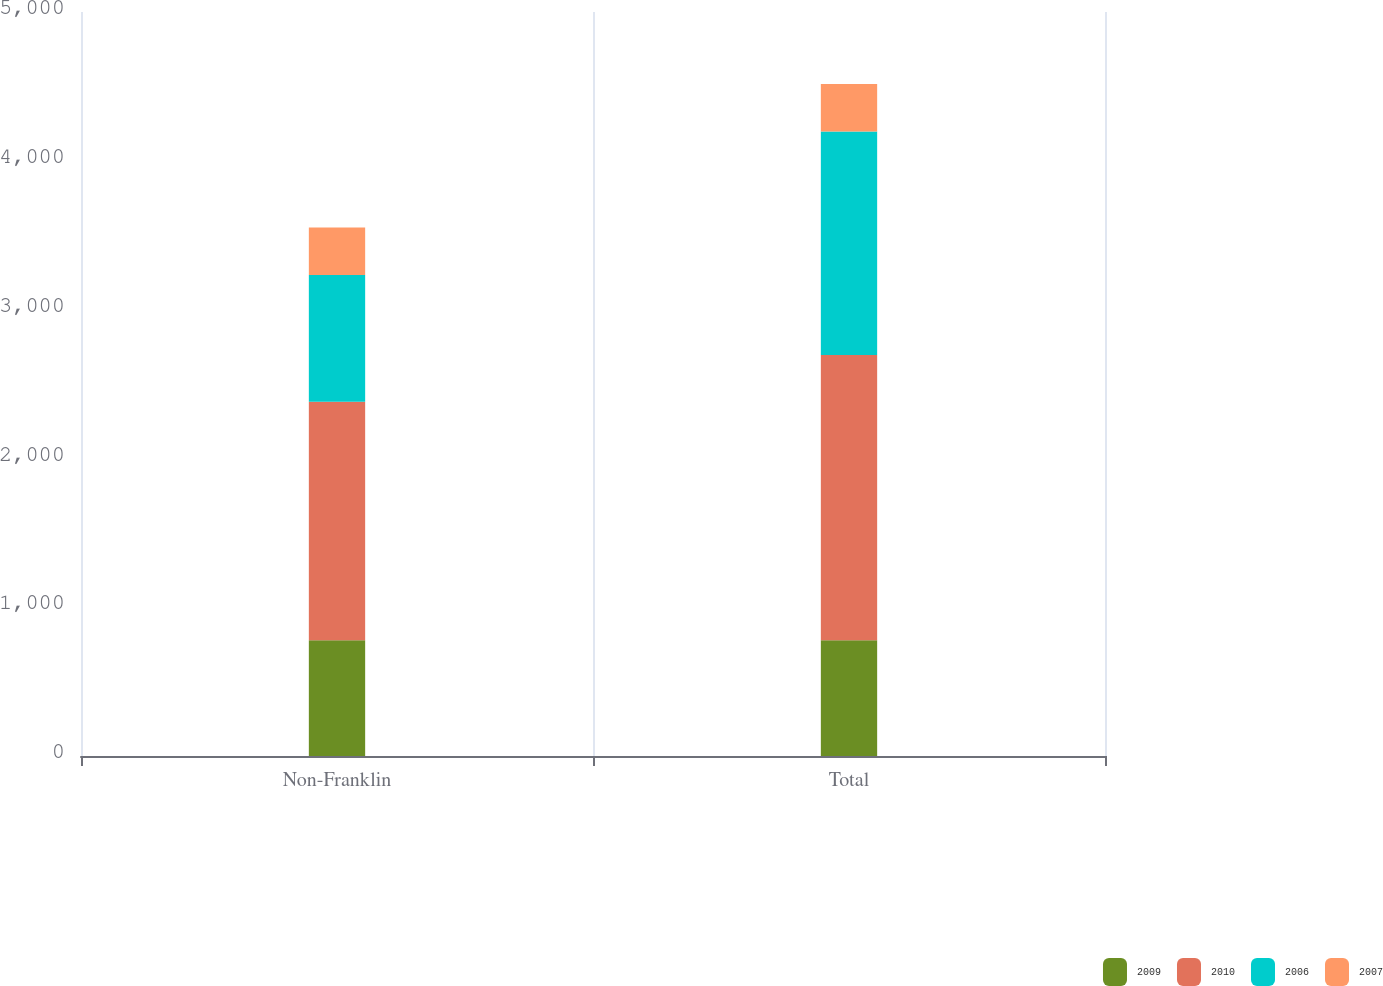Convert chart. <chart><loc_0><loc_0><loc_500><loc_500><stacked_bar_chart><ecel><fcel>Non-Franklin<fcel>Total<nl><fcel>2009<fcel>777.9<fcel>777.9<nl><fcel>2010<fcel>1602.3<fcel>1917<nl><fcel>2006<fcel>851.9<fcel>1502.1<nl><fcel>2007<fcel>319.8<fcel>319.8<nl></chart> 